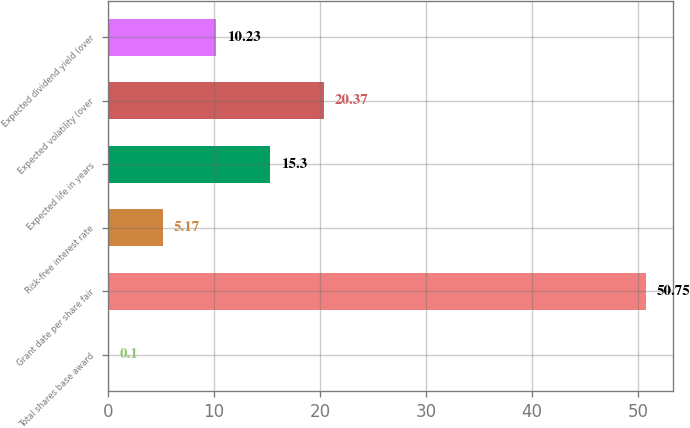Convert chart. <chart><loc_0><loc_0><loc_500><loc_500><bar_chart><fcel>Total shares base award<fcel>Grant date per share fair<fcel>Risk-free interest rate<fcel>Expected life in years<fcel>Expected volatility (over<fcel>Expected dividend yield (over<nl><fcel>0.1<fcel>50.75<fcel>5.17<fcel>15.3<fcel>20.37<fcel>10.23<nl></chart> 